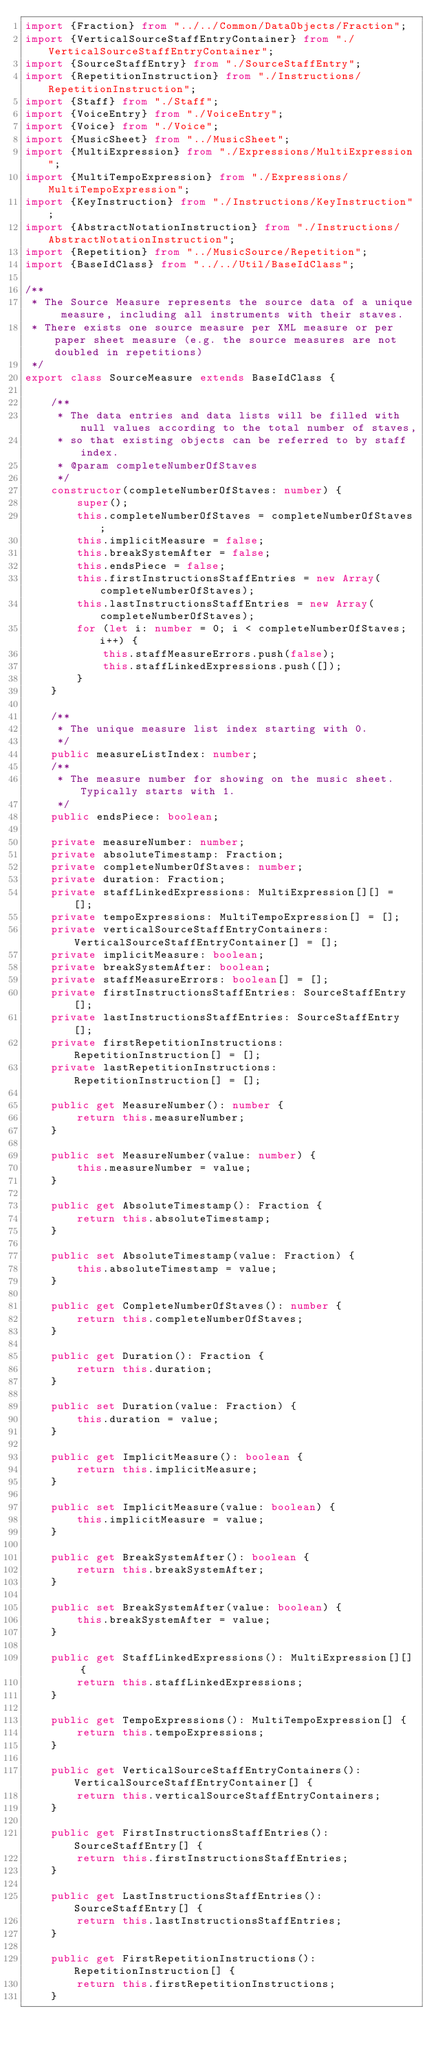Convert code to text. <code><loc_0><loc_0><loc_500><loc_500><_TypeScript_>import {Fraction} from "../../Common/DataObjects/Fraction";
import {VerticalSourceStaffEntryContainer} from "./VerticalSourceStaffEntryContainer";
import {SourceStaffEntry} from "./SourceStaffEntry";
import {RepetitionInstruction} from "./Instructions/RepetitionInstruction";
import {Staff} from "./Staff";
import {VoiceEntry} from "./VoiceEntry";
import {Voice} from "./Voice";
import {MusicSheet} from "../MusicSheet";
import {MultiExpression} from "./Expressions/MultiExpression";
import {MultiTempoExpression} from "./Expressions/MultiTempoExpression";
import {KeyInstruction} from "./Instructions/KeyInstruction";
import {AbstractNotationInstruction} from "./Instructions/AbstractNotationInstruction";
import {Repetition} from "../MusicSource/Repetition";
import {BaseIdClass} from "../../Util/BaseIdClass";

/**
 * The Source Measure represents the source data of a unique measure, including all instruments with their staves.
 * There exists one source measure per XML measure or per paper sheet measure (e.g. the source measures are not doubled in repetitions)
 */
export class SourceMeasure extends BaseIdClass {

    /**
     * The data entries and data lists will be filled with null values according to the total number of staves,
     * so that existing objects can be referred to by staff index.
     * @param completeNumberOfStaves
     */
    constructor(completeNumberOfStaves: number) {
        super();
        this.completeNumberOfStaves = completeNumberOfStaves;
        this.implicitMeasure = false;
        this.breakSystemAfter = false;
        this.endsPiece = false;
        this.firstInstructionsStaffEntries = new Array(completeNumberOfStaves);
        this.lastInstructionsStaffEntries = new Array(completeNumberOfStaves);
        for (let i: number = 0; i < completeNumberOfStaves; i++) {
            this.staffMeasureErrors.push(false);
            this.staffLinkedExpressions.push([]);
        }
    }

    /**
     * The unique measure list index starting with 0.
     */
    public measureListIndex: number;
    /**
     * The measure number for showing on the music sheet. Typically starts with 1.
     */
    public endsPiece: boolean;

    private measureNumber: number;
    private absoluteTimestamp: Fraction;
    private completeNumberOfStaves: number;
    private duration: Fraction;
    private staffLinkedExpressions: MultiExpression[][] = [];
    private tempoExpressions: MultiTempoExpression[] = [];
    private verticalSourceStaffEntryContainers: VerticalSourceStaffEntryContainer[] = [];
    private implicitMeasure: boolean;
    private breakSystemAfter: boolean;
    private staffMeasureErrors: boolean[] = [];
    private firstInstructionsStaffEntries: SourceStaffEntry[];
    private lastInstructionsStaffEntries: SourceStaffEntry[];
    private firstRepetitionInstructions: RepetitionInstruction[] = [];
    private lastRepetitionInstructions: RepetitionInstruction[] = [];

    public get MeasureNumber(): number {
        return this.measureNumber;
    }

    public set MeasureNumber(value: number) {
        this.measureNumber = value;
    }

    public get AbsoluteTimestamp(): Fraction {
        return this.absoluteTimestamp;
    }

    public set AbsoluteTimestamp(value: Fraction) {
        this.absoluteTimestamp = value;
    }

    public get CompleteNumberOfStaves(): number {
        return this.completeNumberOfStaves;
    }

    public get Duration(): Fraction {
        return this.duration;
    }

    public set Duration(value: Fraction) {
        this.duration = value;
    }

    public get ImplicitMeasure(): boolean {
        return this.implicitMeasure;
    }

    public set ImplicitMeasure(value: boolean) {
        this.implicitMeasure = value;
    }

    public get BreakSystemAfter(): boolean {
        return this.breakSystemAfter;
    }

    public set BreakSystemAfter(value: boolean) {
        this.breakSystemAfter = value;
    }

    public get StaffLinkedExpressions(): MultiExpression[][] {
        return this.staffLinkedExpressions;
    }

    public get TempoExpressions(): MultiTempoExpression[] {
        return this.tempoExpressions;
    }

    public get VerticalSourceStaffEntryContainers(): VerticalSourceStaffEntryContainer[] {
        return this.verticalSourceStaffEntryContainers;
    }

    public get FirstInstructionsStaffEntries(): SourceStaffEntry[] {
        return this.firstInstructionsStaffEntries;
    }

    public get LastInstructionsStaffEntries(): SourceStaffEntry[] {
        return this.lastInstructionsStaffEntries;
    }

    public get FirstRepetitionInstructions(): RepetitionInstruction[] {
        return this.firstRepetitionInstructions;
    }
</code> 